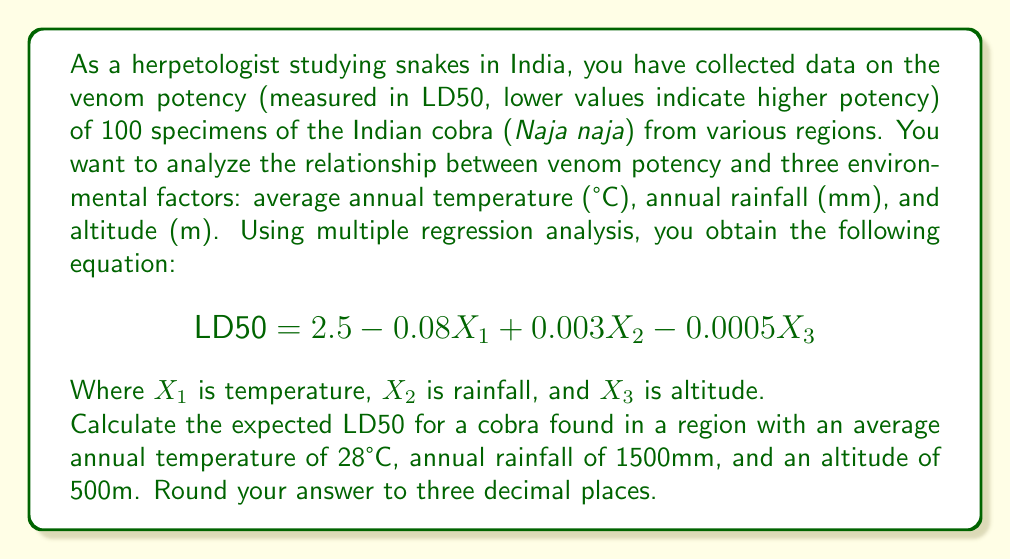Can you answer this question? To solve this problem, we need to use the multiple regression equation provided and substitute the given values for each variable. Let's break it down step-by-step:

1. The multiple regression equation is:
   $$\text{LD50} = 2.5 - 0.08X_1 + 0.003X_2 - 0.0005X_3$$

2. We are given the following values:
   $X_1$ (temperature) = 28°C
   $X_2$ (rainfall) = 1500mm
   $X_3$ (altitude) = 500m

3. Let's substitute these values into the equation:
   $$\text{LD50} = 2.5 - 0.08(28) + 0.003(1500) - 0.0005(500)$$

4. Now, let's calculate each term:
   - $2.5$ (constant term)
   - $-0.08(28) = -2.24$
   - $0.003(1500) = 4.5$
   - $-0.0005(500) = -0.25$

5. Sum up all the terms:
   $$\text{LD50} = 2.5 - 2.24 + 4.5 - 0.25$$

6. Perform the final calculation:
   $$\text{LD50} = 4.51$$

7. Round to three decimal places:
   $$\text{LD50} = 4.510$$
Answer: 4.510 